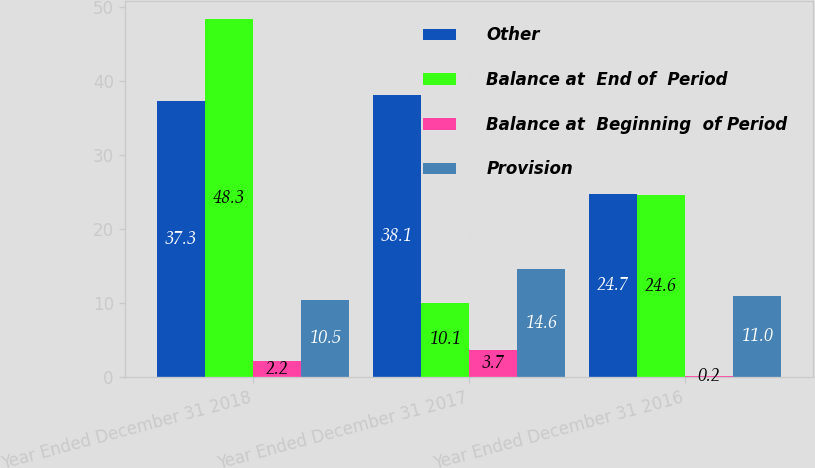Convert chart. <chart><loc_0><loc_0><loc_500><loc_500><stacked_bar_chart><ecel><fcel>Year Ended December 31 2018<fcel>Year Ended December 31 2017<fcel>Year Ended December 31 2016<nl><fcel>Other<fcel>37.3<fcel>38.1<fcel>24.7<nl><fcel>Balance at  End of  Period<fcel>48.3<fcel>10.1<fcel>24.6<nl><fcel>Balance at  Beginning  of Period<fcel>2.2<fcel>3.7<fcel>0.2<nl><fcel>Provision<fcel>10.5<fcel>14.6<fcel>11<nl></chart> 